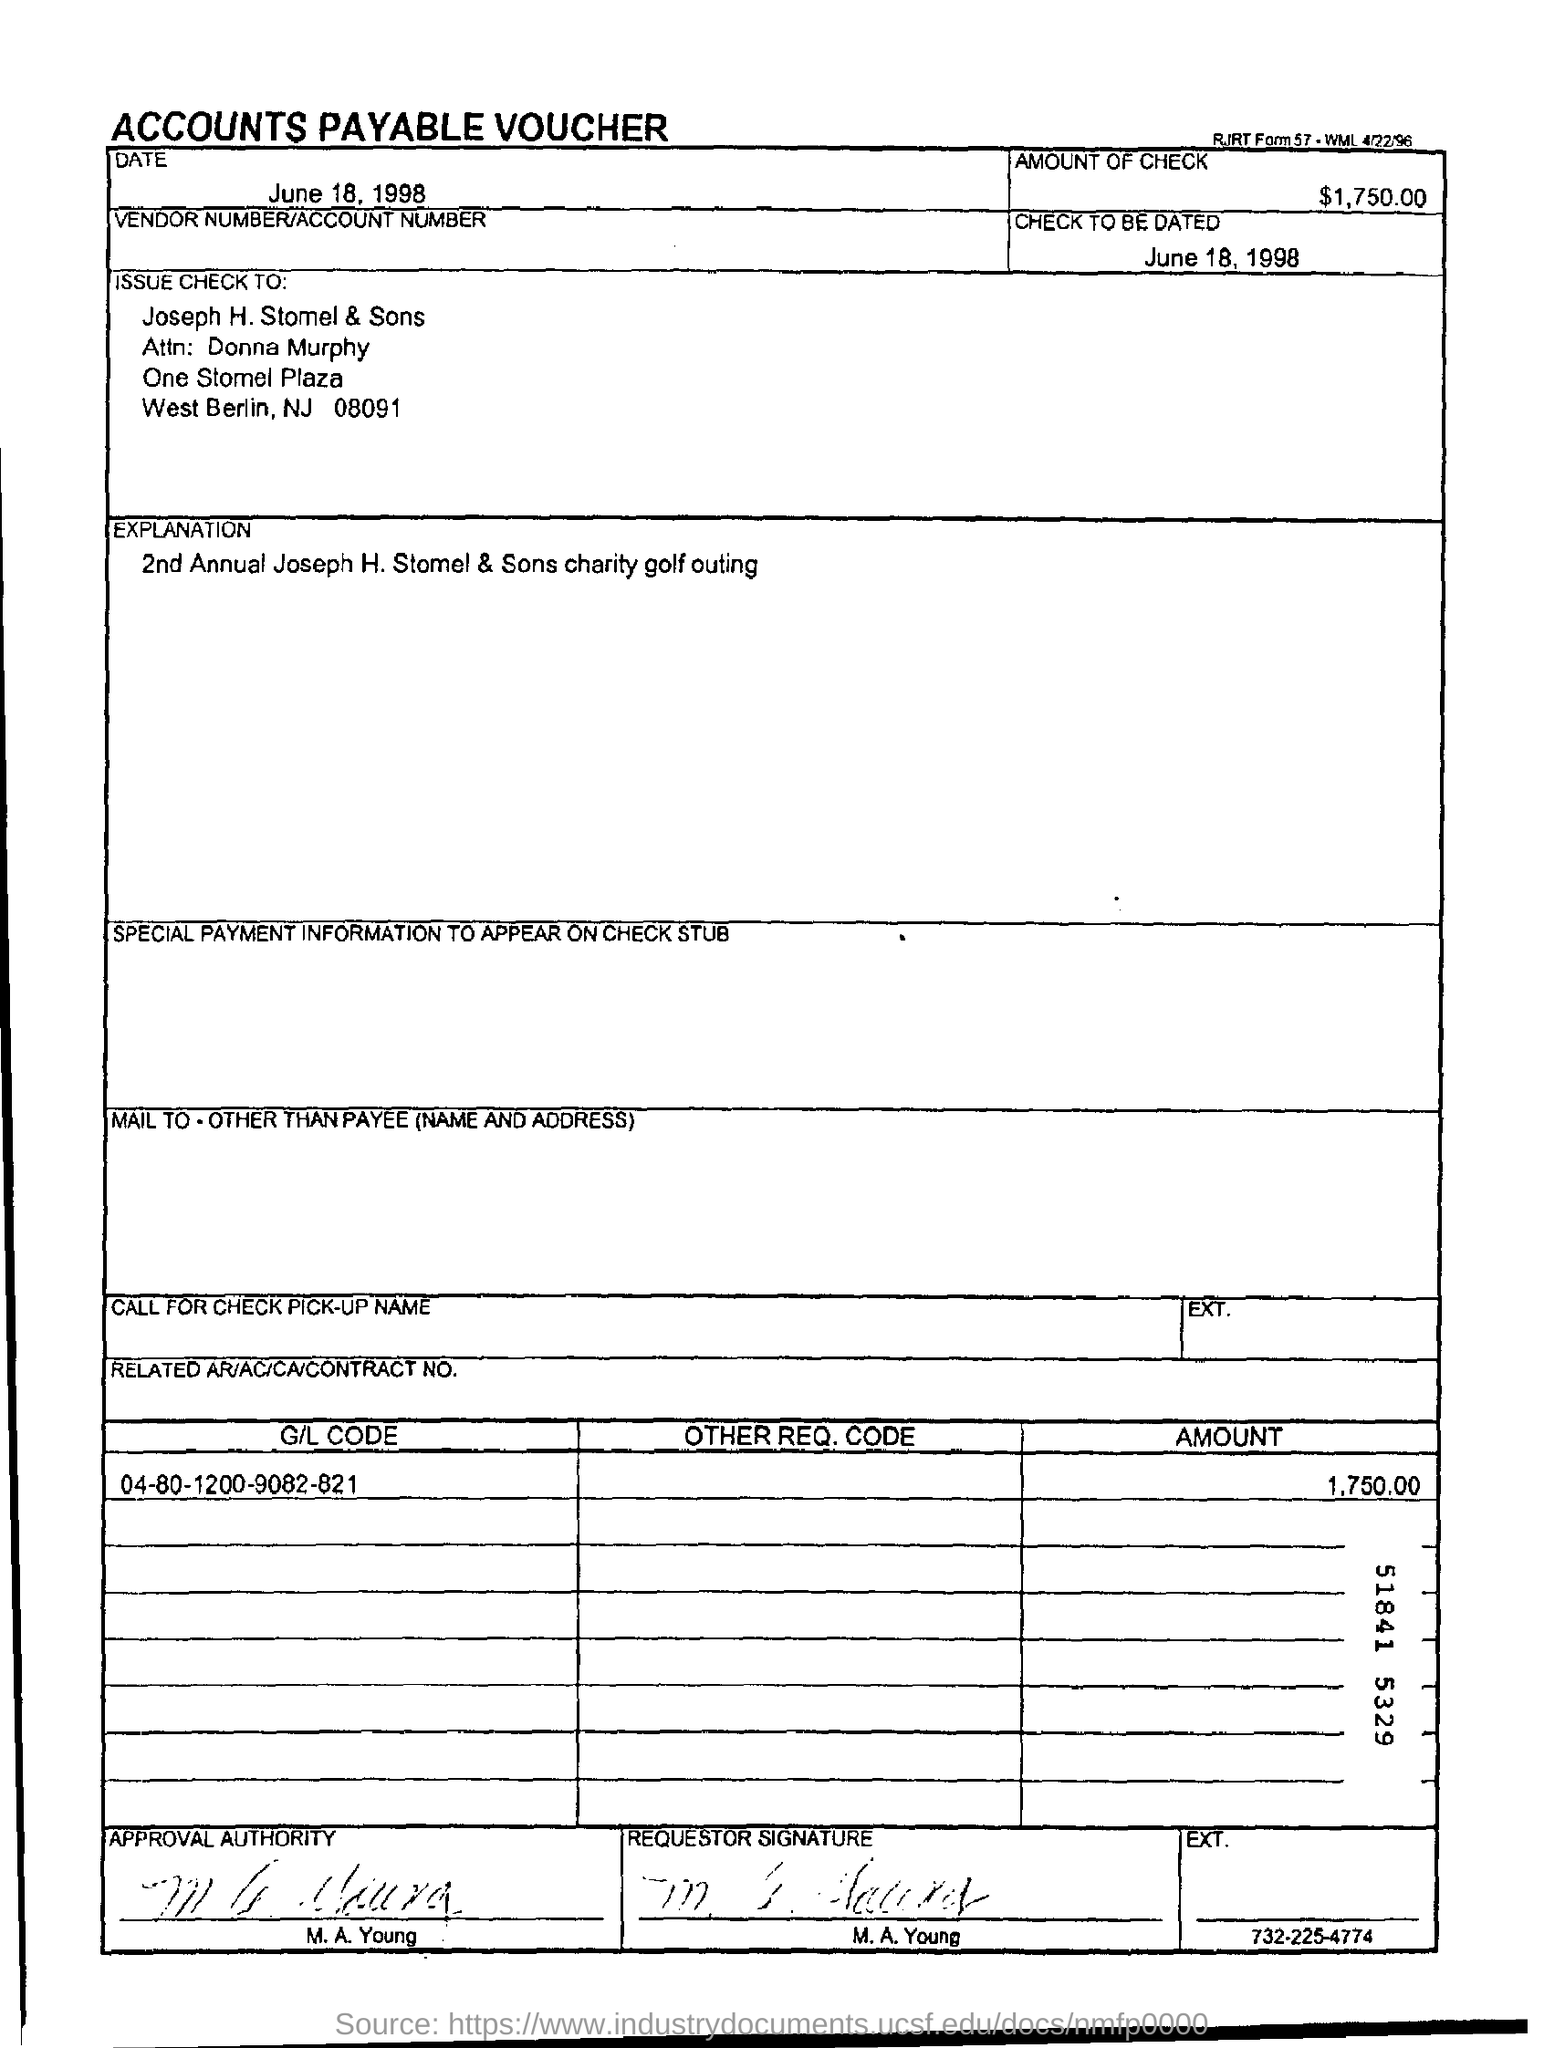What type of voucher is given here?
Your answer should be very brief. ACCOUNTS PAYABLE VOUCHER. What is the date mentioned in the voucher?
Your answer should be compact. June 18, 1998. What is the amount of check mentioned in the voucher?
Offer a terse response. $1,750.00. In whose name, the check is issued?
Provide a succinct answer. Joseph H. Stomel & Sons. What is the check to be dated?
Make the answer very short. June 18, 1998. What is the G/L Code mentioned in the voucher?
Keep it short and to the point. 04-80-1200-9082-821. 